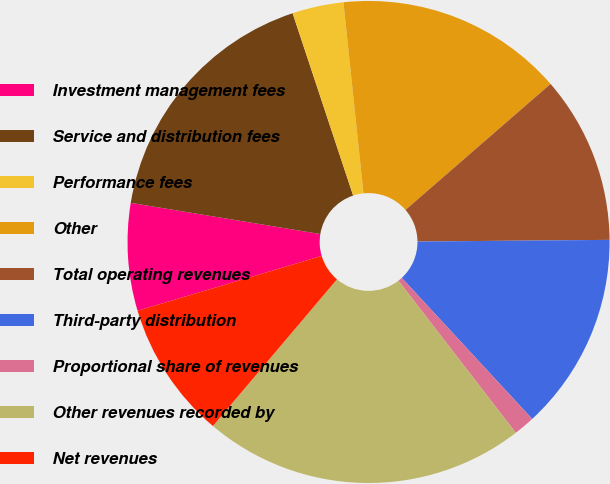Convert chart to OTSL. <chart><loc_0><loc_0><loc_500><loc_500><pie_chart><fcel>Investment management fees<fcel>Service and distribution fees<fcel>Performance fees<fcel>Other<fcel>Total operating revenues<fcel>Third-party distribution<fcel>Proportional share of revenues<fcel>Other revenues recorded by<fcel>Net revenues<nl><fcel>7.2%<fcel>17.3%<fcel>3.44%<fcel>15.28%<fcel>11.24%<fcel>13.26%<fcel>1.42%<fcel>21.63%<fcel>9.22%<nl></chart> 